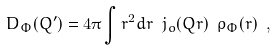<formula> <loc_0><loc_0><loc_500><loc_500>D _ { \Phi } ( Q ^ { \prime } ) = 4 \pi \int r ^ { 2 } d r \ j _ { o } ( Q r ) \ \rho _ { \Phi } ( r ) \ ,</formula> 